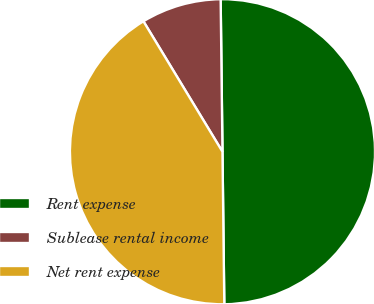Convert chart to OTSL. <chart><loc_0><loc_0><loc_500><loc_500><pie_chart><fcel>Rent expense<fcel>Sublease rental income<fcel>Net rent expense<nl><fcel>50.0%<fcel>8.48%<fcel>41.52%<nl></chart> 